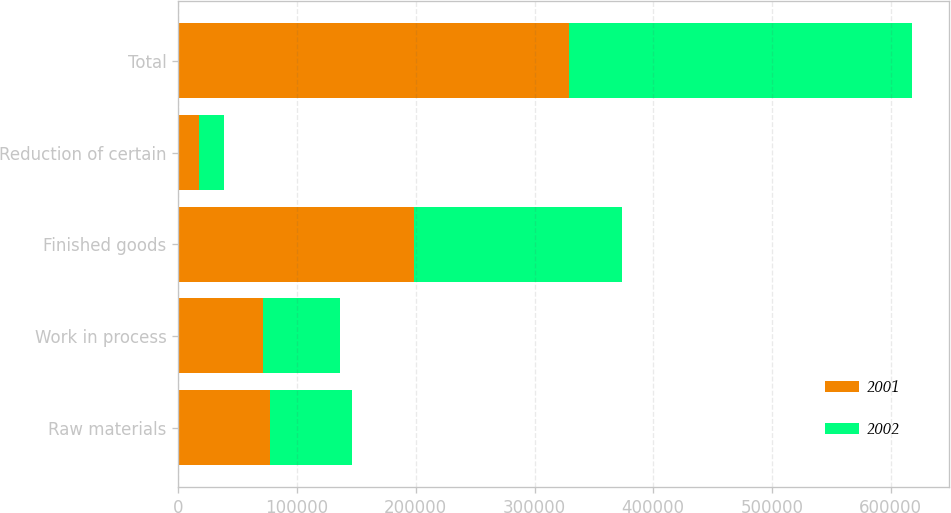Convert chart. <chart><loc_0><loc_0><loc_500><loc_500><stacked_bar_chart><ecel><fcel>Raw materials<fcel>Work in process<fcel>Finished goods<fcel>Reduction of certain<fcel>Total<nl><fcel>2001<fcel>76893<fcel>71287<fcel>198440<fcel>17171<fcel>329449<nl><fcel>2002<fcel>69312<fcel>65148<fcel>174968<fcel>20858<fcel>288570<nl></chart> 